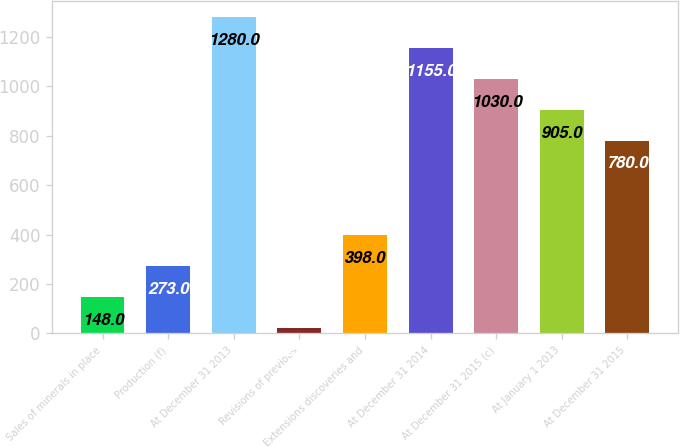Convert chart to OTSL. <chart><loc_0><loc_0><loc_500><loc_500><bar_chart><fcel>Sales of minerals in place<fcel>Production (f)<fcel>At December 31 2013<fcel>Revisions of previous<fcel>Extensions discoveries and<fcel>At December 31 2014<fcel>At December 31 2015 (c)<fcel>At January 1 2013<fcel>At December 31 2015<nl><fcel>148<fcel>273<fcel>1280<fcel>23<fcel>398<fcel>1155<fcel>1030<fcel>905<fcel>780<nl></chart> 